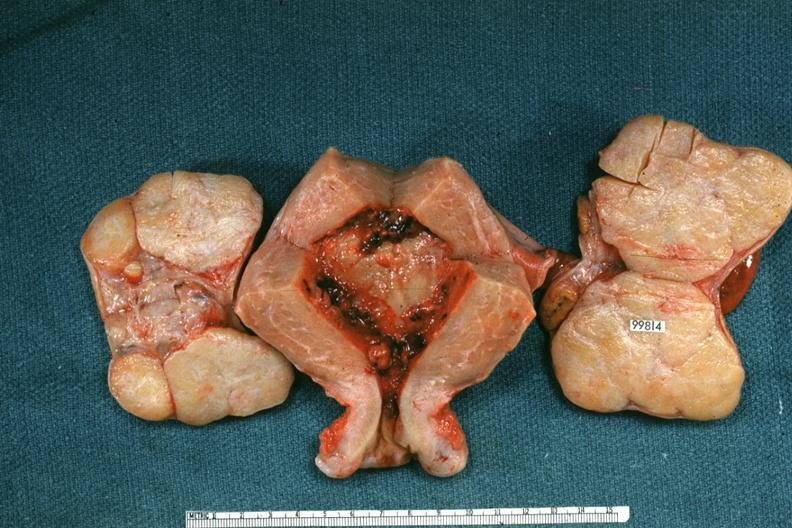does this image show uterus and ovaries with bilateral brenner tumors?
Answer the question using a single word or phrase. Yes 